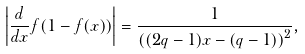<formula> <loc_0><loc_0><loc_500><loc_500>\left | \frac { d } { d x } f ( 1 - f ( x ) ) \right | = \frac { 1 } { \left ( ( 2 q - 1 ) x - ( q - 1 ) \right ) ^ { 2 } } ,</formula> 